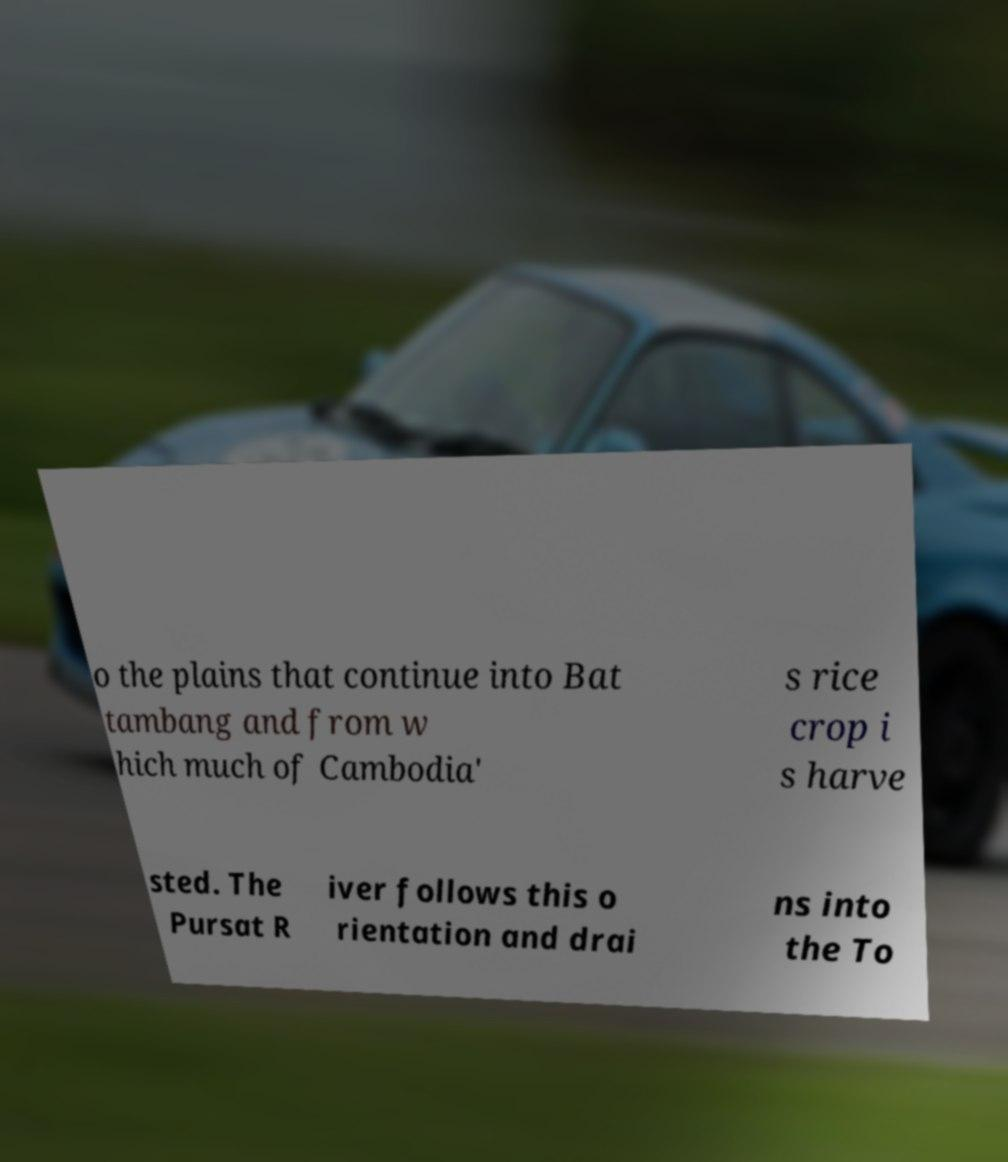For documentation purposes, I need the text within this image transcribed. Could you provide that? o the plains that continue into Bat tambang and from w hich much of Cambodia' s rice crop i s harve sted. The Pursat R iver follows this o rientation and drai ns into the To 